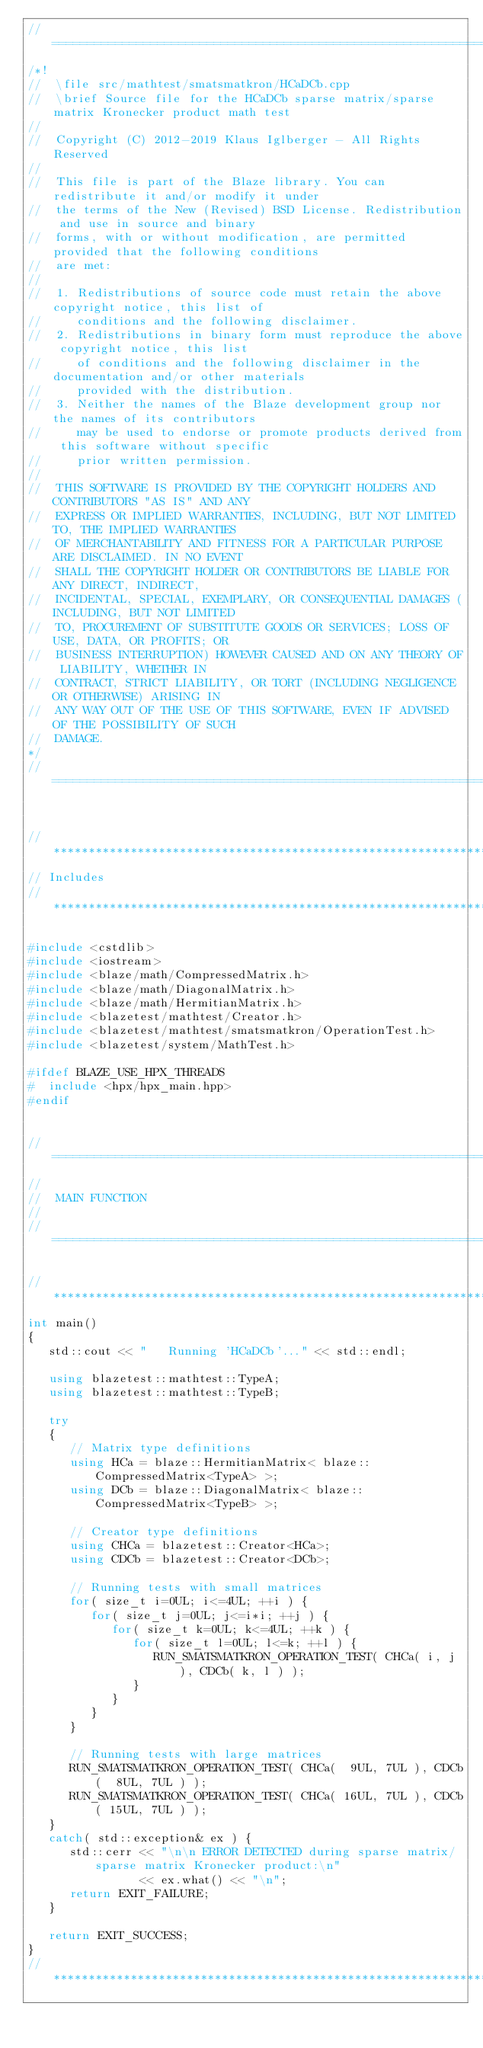Convert code to text. <code><loc_0><loc_0><loc_500><loc_500><_C++_>//=================================================================================================
/*!
//  \file src/mathtest/smatsmatkron/HCaDCb.cpp
//  \brief Source file for the HCaDCb sparse matrix/sparse matrix Kronecker product math test
//
//  Copyright (C) 2012-2019 Klaus Iglberger - All Rights Reserved
//
//  This file is part of the Blaze library. You can redistribute it and/or modify it under
//  the terms of the New (Revised) BSD License. Redistribution and use in source and binary
//  forms, with or without modification, are permitted provided that the following conditions
//  are met:
//
//  1. Redistributions of source code must retain the above copyright notice, this list of
//     conditions and the following disclaimer.
//  2. Redistributions in binary form must reproduce the above copyright notice, this list
//     of conditions and the following disclaimer in the documentation and/or other materials
//     provided with the distribution.
//  3. Neither the names of the Blaze development group nor the names of its contributors
//     may be used to endorse or promote products derived from this software without specific
//     prior written permission.
//
//  THIS SOFTWARE IS PROVIDED BY THE COPYRIGHT HOLDERS AND CONTRIBUTORS "AS IS" AND ANY
//  EXPRESS OR IMPLIED WARRANTIES, INCLUDING, BUT NOT LIMITED TO, THE IMPLIED WARRANTIES
//  OF MERCHANTABILITY AND FITNESS FOR A PARTICULAR PURPOSE ARE DISCLAIMED. IN NO EVENT
//  SHALL THE COPYRIGHT HOLDER OR CONTRIBUTORS BE LIABLE FOR ANY DIRECT, INDIRECT,
//  INCIDENTAL, SPECIAL, EXEMPLARY, OR CONSEQUENTIAL DAMAGES (INCLUDING, BUT NOT LIMITED
//  TO, PROCUREMENT OF SUBSTITUTE GOODS OR SERVICES; LOSS OF USE, DATA, OR PROFITS; OR
//  BUSINESS INTERRUPTION) HOWEVER CAUSED AND ON ANY THEORY OF LIABILITY, WHETHER IN
//  CONTRACT, STRICT LIABILITY, OR TORT (INCLUDING NEGLIGENCE OR OTHERWISE) ARISING IN
//  ANY WAY OUT OF THE USE OF THIS SOFTWARE, EVEN IF ADVISED OF THE POSSIBILITY OF SUCH
//  DAMAGE.
*/
//=================================================================================================


//*************************************************************************************************
// Includes
//*************************************************************************************************

#include <cstdlib>
#include <iostream>
#include <blaze/math/CompressedMatrix.h>
#include <blaze/math/DiagonalMatrix.h>
#include <blaze/math/HermitianMatrix.h>
#include <blazetest/mathtest/Creator.h>
#include <blazetest/mathtest/smatsmatkron/OperationTest.h>
#include <blazetest/system/MathTest.h>

#ifdef BLAZE_USE_HPX_THREADS
#  include <hpx/hpx_main.hpp>
#endif


//=================================================================================================
//
//  MAIN FUNCTION
//
//=================================================================================================

//*************************************************************************************************
int main()
{
   std::cout << "   Running 'HCaDCb'..." << std::endl;

   using blazetest::mathtest::TypeA;
   using blazetest::mathtest::TypeB;

   try
   {
      // Matrix type definitions
      using HCa = blaze::HermitianMatrix< blaze::CompressedMatrix<TypeA> >;
      using DCb = blaze::DiagonalMatrix< blaze::CompressedMatrix<TypeB> >;

      // Creator type definitions
      using CHCa = blazetest::Creator<HCa>;
      using CDCb = blazetest::Creator<DCb>;

      // Running tests with small matrices
      for( size_t i=0UL; i<=4UL; ++i ) {
         for( size_t j=0UL; j<=i*i; ++j ) {
            for( size_t k=0UL; k<=4UL; ++k ) {
               for( size_t l=0UL; l<=k; ++l ) {
                  RUN_SMATSMATKRON_OPERATION_TEST( CHCa( i, j ), CDCb( k, l ) );
               }
            }
         }
      }

      // Running tests with large matrices
      RUN_SMATSMATKRON_OPERATION_TEST( CHCa(  9UL, 7UL ), CDCb(  8UL, 7UL ) );
      RUN_SMATSMATKRON_OPERATION_TEST( CHCa( 16UL, 7UL ), CDCb( 15UL, 7UL ) );
   }
   catch( std::exception& ex ) {
      std::cerr << "\n\n ERROR DETECTED during sparse matrix/sparse matrix Kronecker product:\n"
                << ex.what() << "\n";
      return EXIT_FAILURE;
   }

   return EXIT_SUCCESS;
}
//*************************************************************************************************
</code> 